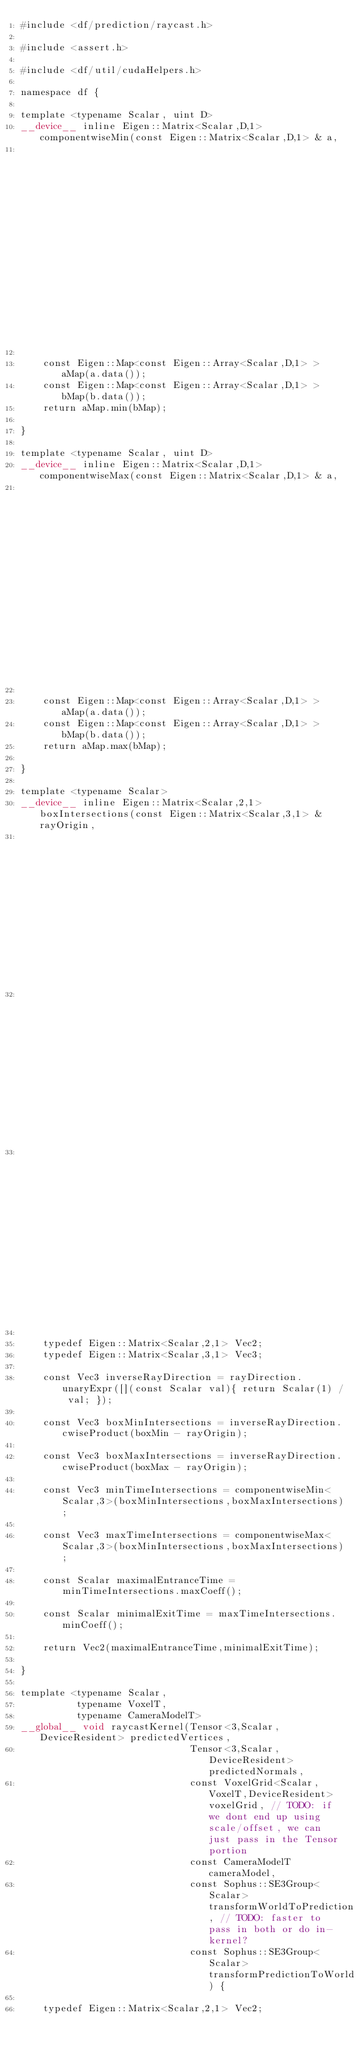Convert code to text. <code><loc_0><loc_0><loc_500><loc_500><_Cuda_>#include <df/prediction/raycast.h>

#include <assert.h>

#include <df/util/cudaHelpers.h>

namespace df {

template <typename Scalar, uint D>
__device__ inline Eigen::Matrix<Scalar,D,1> componentwiseMin(const Eigen::Matrix<Scalar,D,1> & a,
                                                             const Eigen::Matrix<Scalar,D,1> & b) {

    const Eigen::Map<const Eigen::Array<Scalar,D,1> > aMap(a.data());
    const Eigen::Map<const Eigen::Array<Scalar,D,1> > bMap(b.data());
    return aMap.min(bMap);

}

template <typename Scalar, uint D>
__device__ inline Eigen::Matrix<Scalar,D,1> componentwiseMax(const Eigen::Matrix<Scalar,D,1> & a,
                                                             const Eigen::Matrix<Scalar,D,1> & b) {

    const Eigen::Map<const Eigen::Array<Scalar,D,1> > aMap(a.data());
    const Eigen::Map<const Eigen::Array<Scalar,D,1> > bMap(b.data());
    return aMap.max(bMap);

}

template <typename Scalar>
__device__ inline Eigen::Matrix<Scalar,2,1> boxIntersections(const Eigen::Matrix<Scalar,3,1> & rayOrigin,
                                                             const Eigen::Matrix<Scalar,3,1> & rayDirection,
                                                             const Eigen::Matrix<Scalar,3,1> & boxMin,
                                                             const Eigen::Matrix<Scalar,3,1> & boxMax) {

    typedef Eigen::Matrix<Scalar,2,1> Vec2;
    typedef Eigen::Matrix<Scalar,3,1> Vec3;

    const Vec3 inverseRayDirection = rayDirection.unaryExpr([](const Scalar val){ return Scalar(1) / val; });

    const Vec3 boxMinIntersections = inverseRayDirection.cwiseProduct(boxMin - rayOrigin);

    const Vec3 boxMaxIntersections = inverseRayDirection.cwiseProduct(boxMax - rayOrigin);

    const Vec3 minTimeIntersections = componentwiseMin<Scalar,3>(boxMinIntersections,boxMaxIntersections);

    const Vec3 maxTimeIntersections = componentwiseMax<Scalar,3>(boxMinIntersections,boxMaxIntersections);

    const Scalar maximalEntranceTime = minTimeIntersections.maxCoeff();

    const Scalar minimalExitTime = maxTimeIntersections.minCoeff();

    return Vec2(maximalEntranceTime,minimalExitTime);

}

template <typename Scalar,
          typename VoxelT,
          typename CameraModelT>
__global__ void raycastKernel(Tensor<3,Scalar,DeviceResident> predictedVertices,
                              Tensor<3,Scalar,DeviceResident> predictedNormals,
                              const VoxelGrid<Scalar,VoxelT,DeviceResident> voxelGrid, // TODO: if we dont end up using scale/offset, we can just pass in the Tensor portion
                              const CameraModelT cameraModel,
                              const Sophus::SE3Group<Scalar> transformWorldToPrediction, // TODO: faster to pass in both or do in-kernel?
                              const Sophus::SE3Group<Scalar> transformPredictionToWorld) {

    typedef Eigen::Matrix<Scalar,2,1> Vec2;</code> 